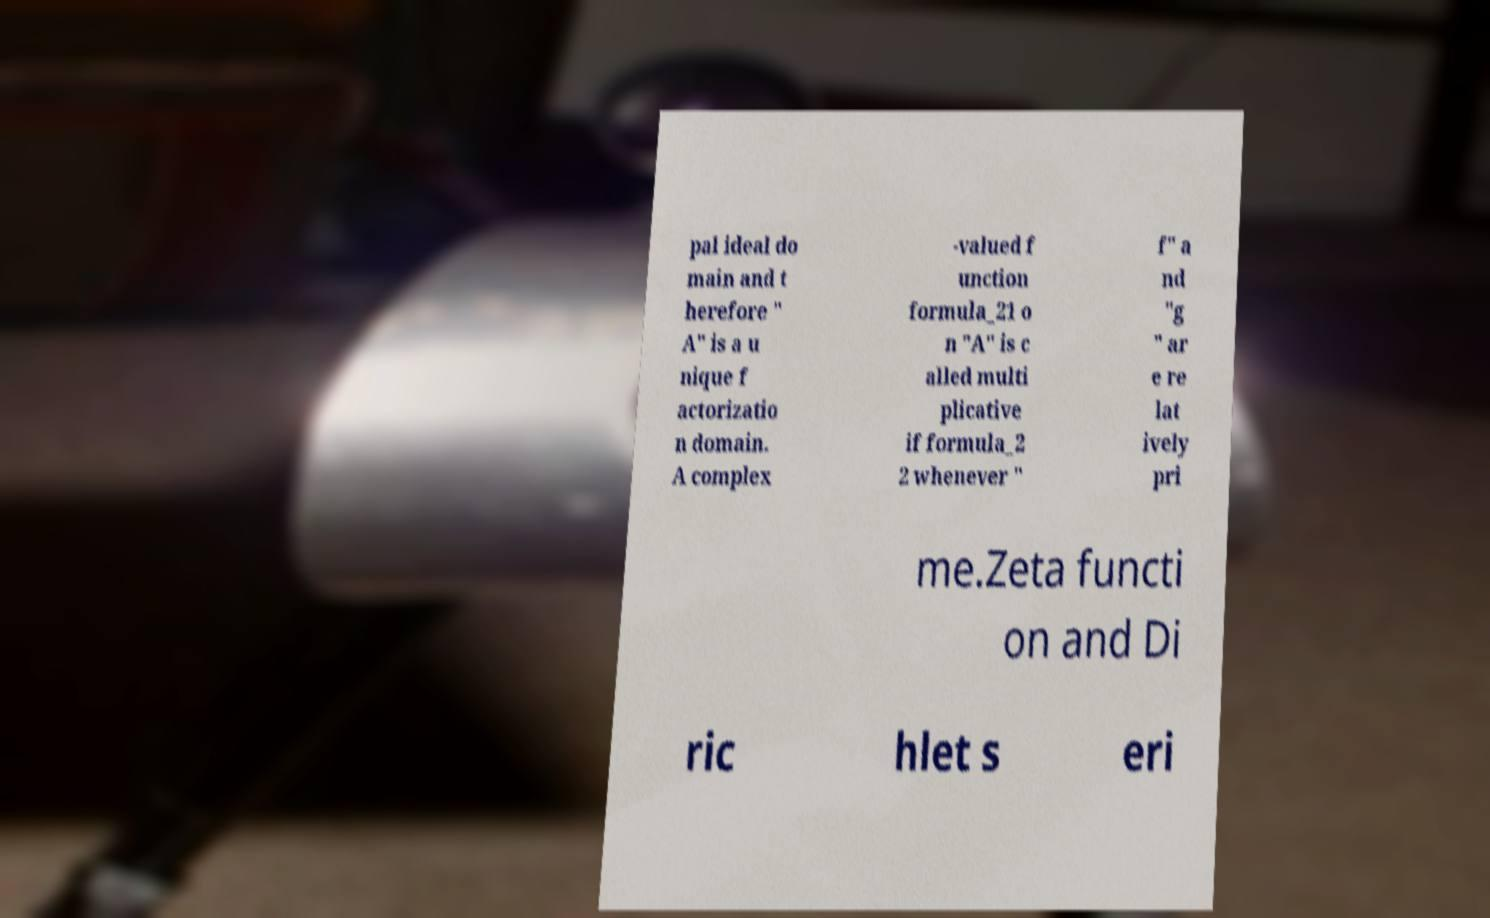There's text embedded in this image that I need extracted. Can you transcribe it verbatim? pal ideal do main and t herefore " A" is a u nique f actorizatio n domain. A complex -valued f unction formula_21 o n "A" is c alled multi plicative if formula_2 2 whenever " f" a nd "g " ar e re lat ively pri me.Zeta functi on and Di ric hlet s eri 